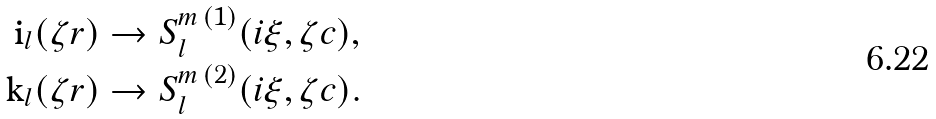Convert formula to latex. <formula><loc_0><loc_0><loc_500><loc_500>\text {i} _ { l } ( \zeta r ) & \to S _ { l } ^ { m \, ( 1 ) } ( i \xi , \zeta c ) , \\ \text {k} _ { l } ( \zeta r ) & \to S _ { l } ^ { m \, ( 2 ) } ( i \xi , \zeta c ) .</formula> 